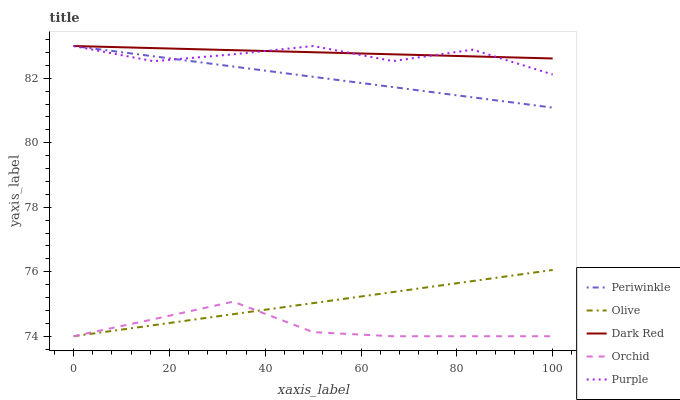Does Orchid have the minimum area under the curve?
Answer yes or no. Yes. Does Dark Red have the maximum area under the curve?
Answer yes or no. Yes. Does Periwinkle have the minimum area under the curve?
Answer yes or no. No. Does Periwinkle have the maximum area under the curve?
Answer yes or no. No. Is Dark Red the smoothest?
Answer yes or no. Yes. Is Purple the roughest?
Answer yes or no. Yes. Is Periwinkle the smoothest?
Answer yes or no. No. Is Periwinkle the roughest?
Answer yes or no. No. Does Olive have the lowest value?
Answer yes or no. Yes. Does Periwinkle have the lowest value?
Answer yes or no. No. Does Purple have the highest value?
Answer yes or no. Yes. Does Orchid have the highest value?
Answer yes or no. No. Is Olive less than Periwinkle?
Answer yes or no. Yes. Is Periwinkle greater than Olive?
Answer yes or no. Yes. Does Orchid intersect Olive?
Answer yes or no. Yes. Is Orchid less than Olive?
Answer yes or no. No. Is Orchid greater than Olive?
Answer yes or no. No. Does Olive intersect Periwinkle?
Answer yes or no. No. 